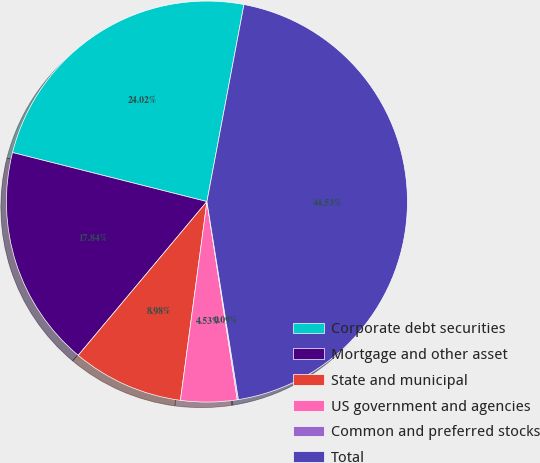<chart> <loc_0><loc_0><loc_500><loc_500><pie_chart><fcel>Corporate debt securities<fcel>Mortgage and other asset<fcel>State and municipal<fcel>US government and agencies<fcel>Common and preferred stocks<fcel>Total<nl><fcel>24.02%<fcel>17.84%<fcel>8.98%<fcel>4.53%<fcel>0.09%<fcel>44.53%<nl></chart> 